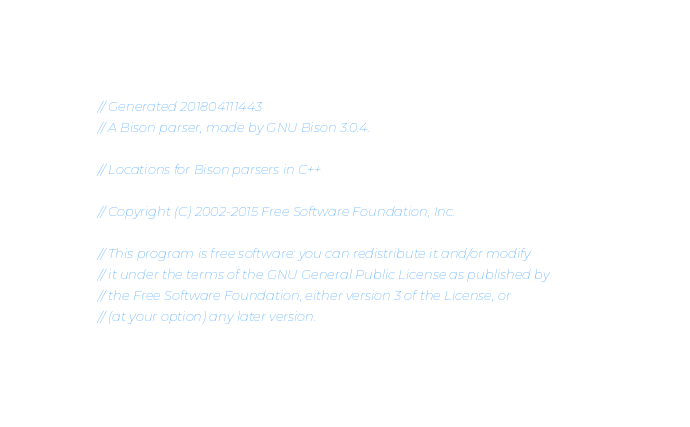Convert code to text. <code><loc_0><loc_0><loc_500><loc_500><_C++_>// Generated 201804111443
// A Bison parser, made by GNU Bison 3.0.4.

// Locations for Bison parsers in C++

// Copyright (C) 2002-2015 Free Software Foundation, Inc.

// This program is free software: you can redistribute it and/or modify
// it under the terms of the GNU General Public License as published by
// the Free Software Foundation, either version 3 of the License, or
// (at your option) any later version.
</code> 